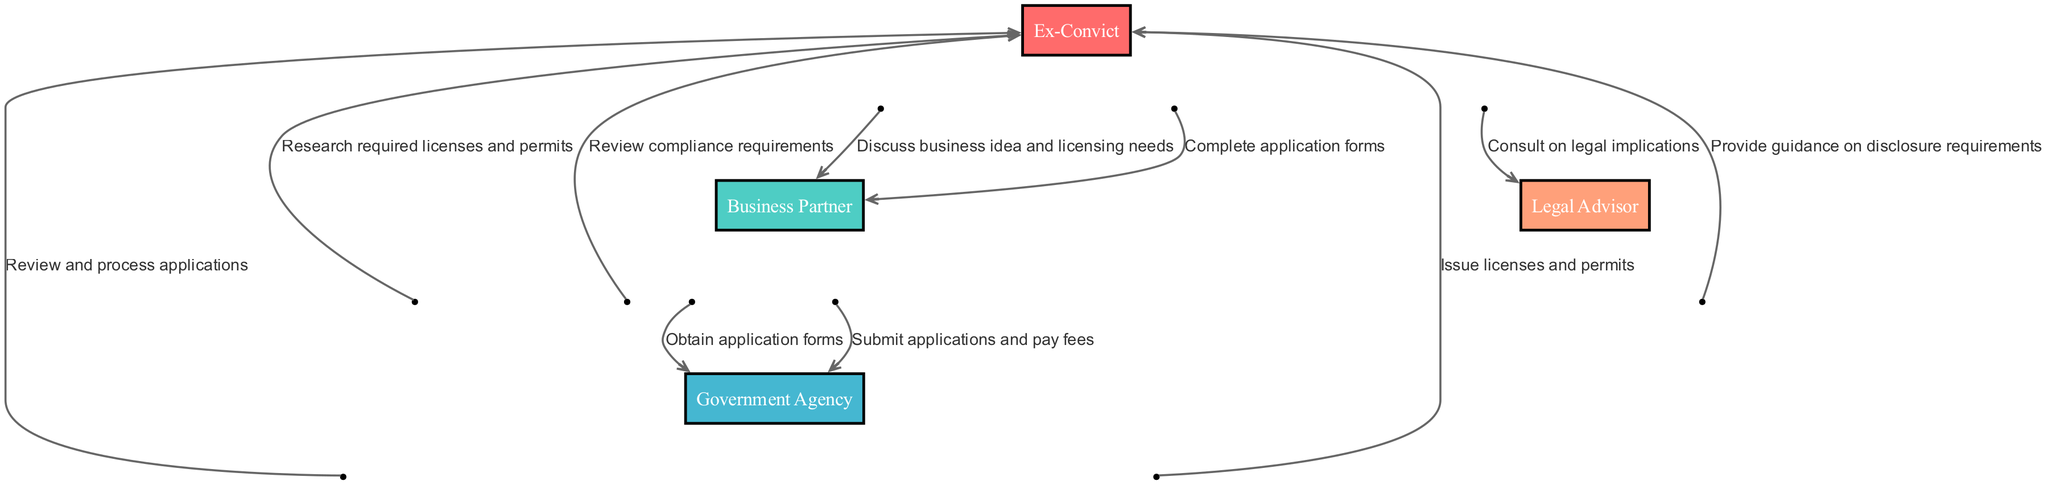What are the actors involved in the process? The diagram outlines four actors involved in the licensing process: Ex-Convict, Business Partner, Government Agency, and Legal Advisor.
Answer: Ex-Convict, Business Partner, Government Agency, Legal Advisor How many steps are there in the licensing process? The sequence diagram details ten steps that outline the interactions between the actors through the licensing process.
Answer: Ten steps Who provides guidance on disclosure requirements? According to the sequence, the Legal Advisor communicates with the Ex-Convict to provide guidance on disclosure requirements.
Answer: Legal Advisor What is the first step in the sequence? The first step shows the Ex-Convict discussing the business idea and licensing needs with the Business Partner, indicating the starting point of the process.
Answer: Discuss business idea and licensing needs Which actor is responsible for submitting applications and paying fees? The Business Partner is responsible for submitting applications and paying the associated fees to the Government Agency at a later step in the sequence.
Answer: Business Partner What does the Government Agency do after receiving the applications? After the applications are submitted, the Government Agency reviews and processes them before issuing licenses and permits.
Answer: Review and process applications What type of support does the Business Partner provide after application completion? Following the completion of application forms, the Business Partner is responsible for reviewing compliance requirements for the Ex-Convict.
Answer: Review compliance requirements Describe the nature of the interaction between the Ex-Convict and Legal Advisor. The interaction is consultative; the Ex-Convict reaches out to the Legal Advisor to understand the legal implications associated with obtaining business licenses and permits.
Answer: Consult on legal implications When are licenses and permits issued in the process? Licenses and permits are issued by the Government Agency after they have reviewed and processed the applications submitted by the Business Partner.
Answer: Issue licenses and permits Which two actors communicate when the application forms are obtained? The Business Partner communicates with the Government Agency to obtain the application forms at this stage of the sequence.
Answer: Business Partner, Government Agency 